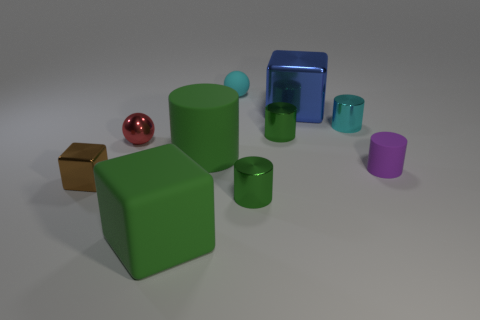Do the large matte block and the small rubber ball have the same color?
Provide a succinct answer. No. There is a small object that is the same material as the tiny purple cylinder; what is its shape?
Your answer should be compact. Sphere. How many cyan things have the same shape as the small brown object?
Your response must be concise. 0. There is a small green thing behind the small green metallic thing that is in front of the tiny brown cube; what shape is it?
Your answer should be compact. Cylinder. Does the sphere that is in front of the cyan rubber object have the same size as the large matte block?
Give a very brief answer. No. What is the size of the green object that is in front of the red thing and right of the tiny cyan matte sphere?
Your answer should be compact. Small. What number of blue rubber objects are the same size as the red metal sphere?
Offer a very short reply. 0. What number of green rubber objects are to the right of the large green thing that is in front of the tiny brown metallic object?
Provide a succinct answer. 1. There is a shiny cylinder that is on the right side of the blue metal thing; is its color the same as the tiny rubber ball?
Provide a succinct answer. Yes. There is a big green rubber thing in front of the green cylinder in front of the tiny purple object; is there a brown thing right of it?
Your answer should be compact. No. 